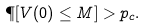Convert formula to latex. <formula><loc_0><loc_0><loc_500><loc_500>\P [ V ( 0 ) \leq M ] > p _ { c } .</formula> 